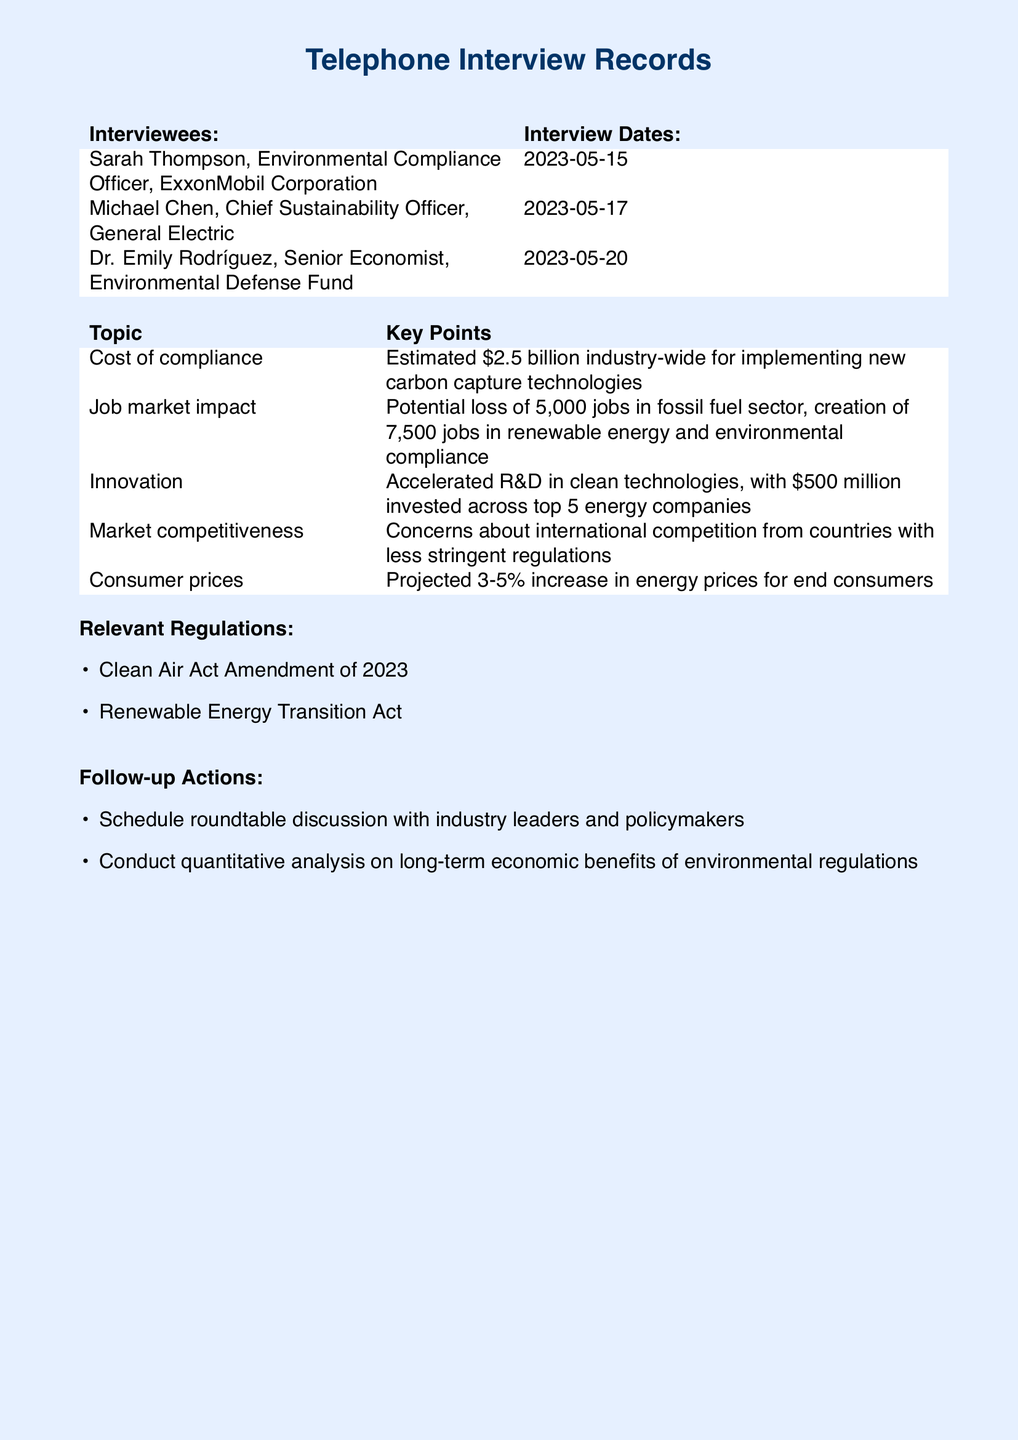What is the name of the Environmental Compliance Officer interviewed? The document lists Sarah Thompson as the Environmental Compliance Officer at ExxonMobil Corporation.
Answer: Sarah Thompson When was the interview with the Chief Sustainability Officer conducted? The interview with Michael Chen, the Chief Sustainability Officer of General Electric, was on May 17, 2023.
Answer: 2023-05-17 How much is the estimated cost of compliance for the new regulations? The document states the estimated cost of compliance is $2.5 billion industry-wide.
Answer: $2.5 billion What is the projected increase in consumer energy prices? The document indicates a projected increase of 3-5% in energy prices for end consumers.
Answer: 3-5% How many jobs are projected to be lost in the fossil fuel sector? The document mentions a potential loss of 5,000 jobs in the fossil fuel sector due to the new regulations.
Answer: 5,000 What is one follow-up action mentioned in the document? The follow-up actions include scheduling a roundtable discussion with industry leaders and policymakers.
Answer: Schedule roundtable discussion What was one of the relevant regulations discussed in the interviews? The document cites the Clean Air Act Amendment of 2023 as one of the relevant regulations.
Answer: Clean Air Act Amendment of 2023 What is the anticipated job creation in renewable energy and environmental compliance? According to the document, there is a potential creation of 7,500 jobs in renewable energy and environmental compliance.
Answer: 7,500 How much money was invested in R&D in clean technologies? The document specifies that $500 million was invested in R&D across the top five energy companies.
Answer: $500 million 